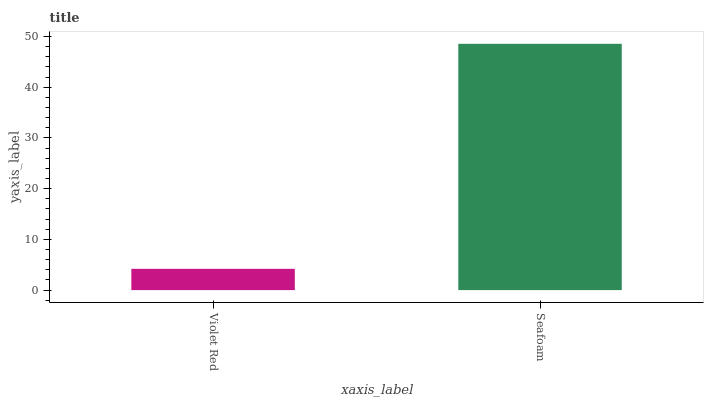Is Violet Red the minimum?
Answer yes or no. Yes. Is Seafoam the maximum?
Answer yes or no. Yes. Is Seafoam the minimum?
Answer yes or no. No. Is Seafoam greater than Violet Red?
Answer yes or no. Yes. Is Violet Red less than Seafoam?
Answer yes or no. Yes. Is Violet Red greater than Seafoam?
Answer yes or no. No. Is Seafoam less than Violet Red?
Answer yes or no. No. Is Seafoam the high median?
Answer yes or no. Yes. Is Violet Red the low median?
Answer yes or no. Yes. Is Violet Red the high median?
Answer yes or no. No. Is Seafoam the low median?
Answer yes or no. No. 